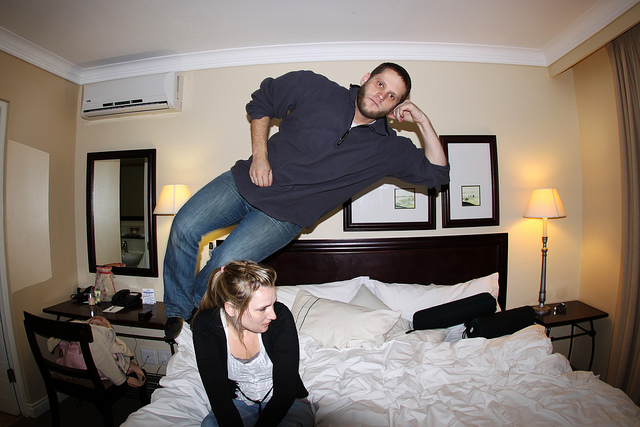Can you describe the setting of this photo? The photo is set in a well-appointed hotel room, featuring a large bed with rumpled sheets, two nightstands, and a pair of lamps. There is also a mirror and a framed picture on the wall, contributing to the cozy ambience of the space. 